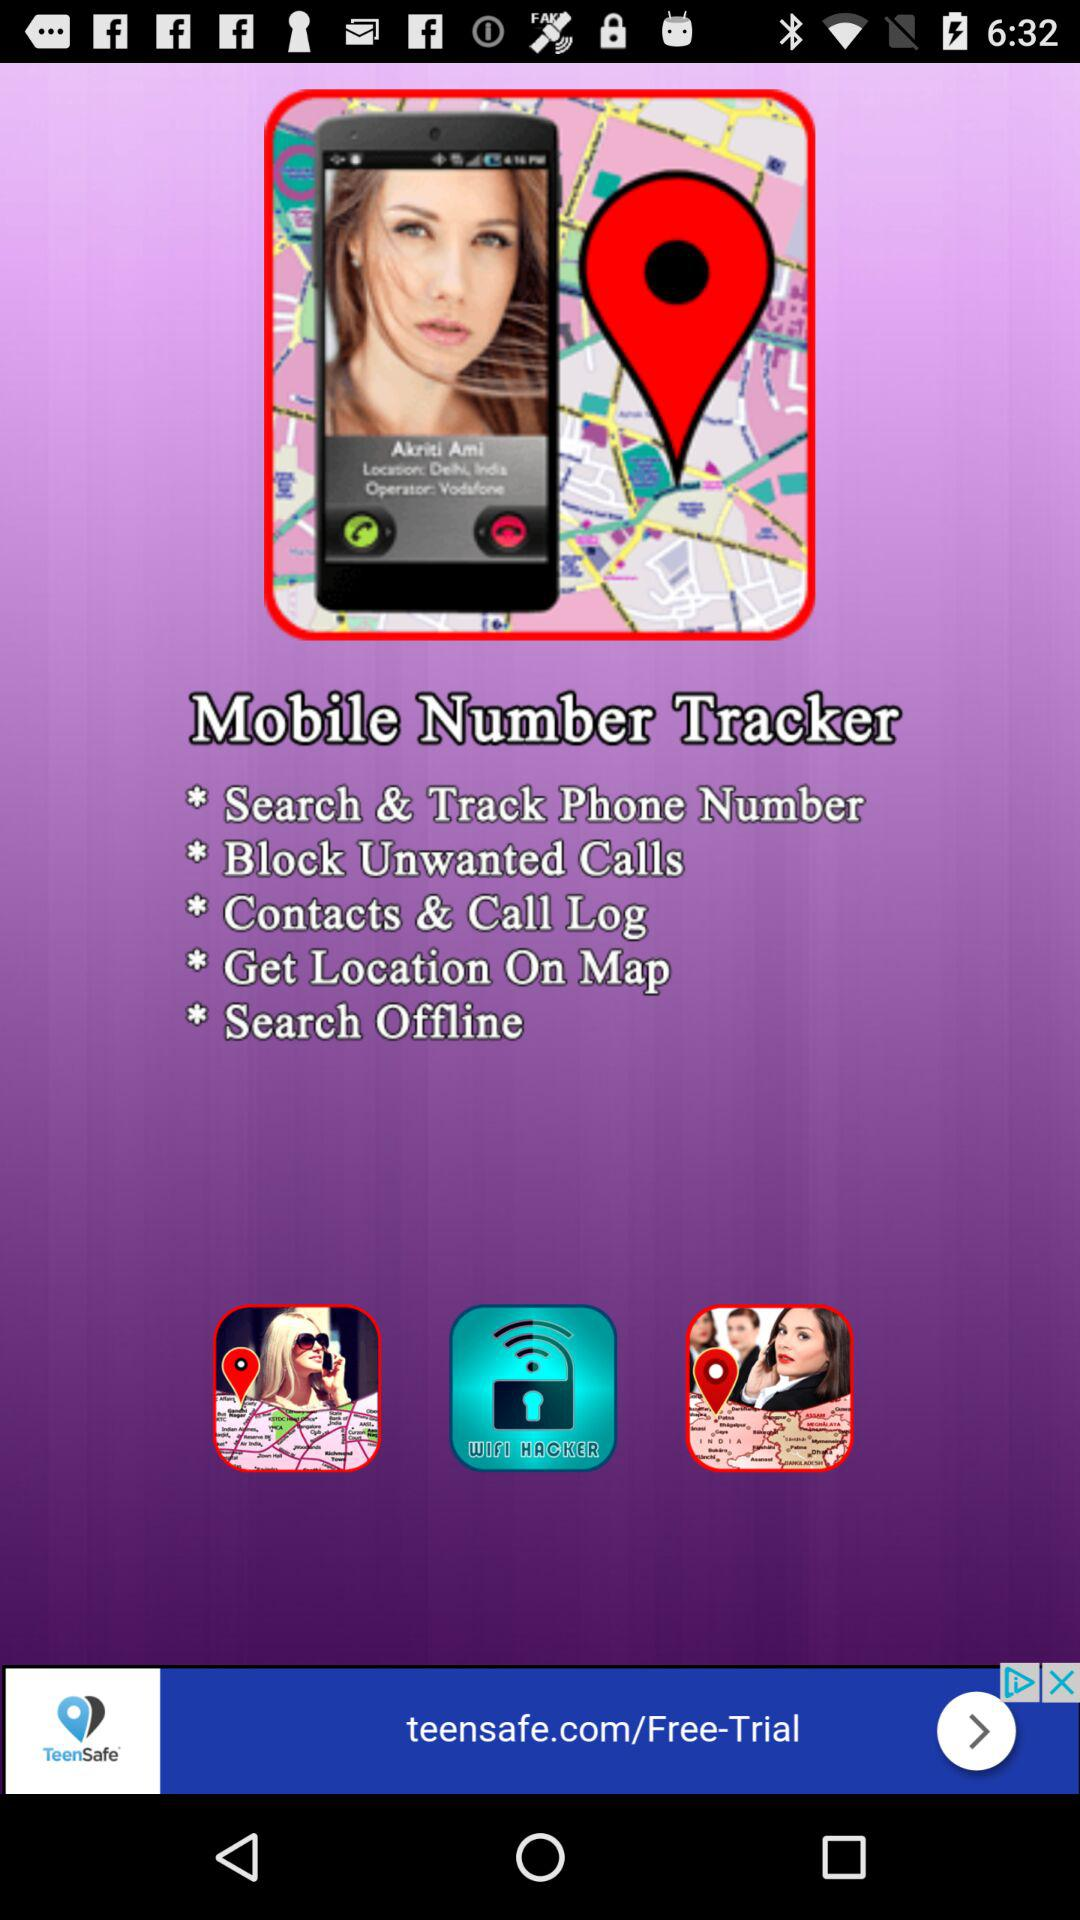What is the name of the application? The application's name is "Mobile Number Tracker". 